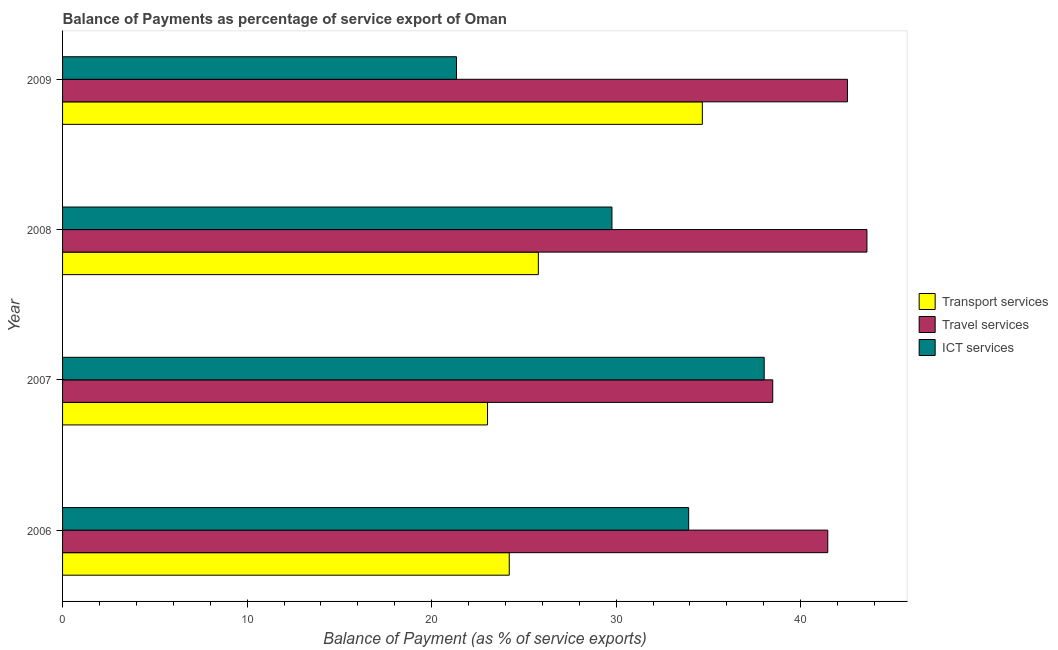How many different coloured bars are there?
Your answer should be compact. 3. How many groups of bars are there?
Make the answer very short. 4. How many bars are there on the 1st tick from the top?
Offer a terse response. 3. What is the balance of payment of ict services in 2008?
Provide a short and direct response. 29.77. Across all years, what is the maximum balance of payment of travel services?
Provide a short and direct response. 43.59. Across all years, what is the minimum balance of payment of ict services?
Keep it short and to the point. 21.35. What is the total balance of payment of ict services in the graph?
Your answer should be compact. 123.07. What is the difference between the balance of payment of ict services in 2006 and that in 2008?
Keep it short and to the point. 4.16. What is the difference between the balance of payment of ict services in 2006 and the balance of payment of travel services in 2008?
Provide a short and direct response. -9.66. What is the average balance of payment of transport services per year?
Provide a succinct answer. 26.92. In the year 2008, what is the difference between the balance of payment of travel services and balance of payment of ict services?
Offer a terse response. 13.82. What is the ratio of the balance of payment of travel services in 2006 to that in 2007?
Your answer should be very brief. 1.08. Is the balance of payment of ict services in 2006 less than that in 2009?
Offer a very short reply. No. Is the difference between the balance of payment of transport services in 2007 and 2009 greater than the difference between the balance of payment of travel services in 2007 and 2009?
Offer a terse response. No. What is the difference between the highest and the second highest balance of payment of travel services?
Your answer should be compact. 1.05. What is the difference between the highest and the lowest balance of payment of transport services?
Make the answer very short. 11.64. What does the 2nd bar from the top in 2006 represents?
Give a very brief answer. Travel services. What does the 2nd bar from the bottom in 2007 represents?
Your response must be concise. Travel services. Are all the bars in the graph horizontal?
Make the answer very short. Yes. Are the values on the major ticks of X-axis written in scientific E-notation?
Your answer should be compact. No. Does the graph contain grids?
Offer a very short reply. No. What is the title of the graph?
Offer a terse response. Balance of Payments as percentage of service export of Oman. Does "Nuclear sources" appear as one of the legend labels in the graph?
Make the answer very short. No. What is the label or title of the X-axis?
Give a very brief answer. Balance of Payment (as % of service exports). What is the Balance of Payment (as % of service exports) of Transport services in 2006?
Give a very brief answer. 24.21. What is the Balance of Payment (as % of service exports) of Travel services in 2006?
Your answer should be very brief. 41.47. What is the Balance of Payment (as % of service exports) in ICT services in 2006?
Your response must be concise. 33.93. What is the Balance of Payment (as % of service exports) of Transport services in 2007?
Provide a succinct answer. 23.03. What is the Balance of Payment (as % of service exports) in Travel services in 2007?
Give a very brief answer. 38.49. What is the Balance of Payment (as % of service exports) in ICT services in 2007?
Keep it short and to the point. 38.02. What is the Balance of Payment (as % of service exports) of Transport services in 2008?
Make the answer very short. 25.78. What is the Balance of Payment (as % of service exports) of Travel services in 2008?
Keep it short and to the point. 43.59. What is the Balance of Payment (as % of service exports) of ICT services in 2008?
Provide a short and direct response. 29.77. What is the Balance of Payment (as % of service exports) in Transport services in 2009?
Offer a very short reply. 34.67. What is the Balance of Payment (as % of service exports) in Travel services in 2009?
Your response must be concise. 42.54. What is the Balance of Payment (as % of service exports) in ICT services in 2009?
Your answer should be very brief. 21.35. Across all years, what is the maximum Balance of Payment (as % of service exports) in Transport services?
Make the answer very short. 34.67. Across all years, what is the maximum Balance of Payment (as % of service exports) in Travel services?
Offer a very short reply. 43.59. Across all years, what is the maximum Balance of Payment (as % of service exports) in ICT services?
Your answer should be compact. 38.02. Across all years, what is the minimum Balance of Payment (as % of service exports) of Transport services?
Offer a terse response. 23.03. Across all years, what is the minimum Balance of Payment (as % of service exports) in Travel services?
Provide a short and direct response. 38.49. Across all years, what is the minimum Balance of Payment (as % of service exports) of ICT services?
Make the answer very short. 21.35. What is the total Balance of Payment (as % of service exports) of Transport services in the graph?
Offer a terse response. 107.69. What is the total Balance of Payment (as % of service exports) of Travel services in the graph?
Keep it short and to the point. 166.08. What is the total Balance of Payment (as % of service exports) of ICT services in the graph?
Make the answer very short. 123.07. What is the difference between the Balance of Payment (as % of service exports) in Transport services in 2006 and that in 2007?
Ensure brevity in your answer.  1.18. What is the difference between the Balance of Payment (as % of service exports) in Travel services in 2006 and that in 2007?
Offer a terse response. 2.98. What is the difference between the Balance of Payment (as % of service exports) of ICT services in 2006 and that in 2007?
Provide a succinct answer. -4.09. What is the difference between the Balance of Payment (as % of service exports) in Transport services in 2006 and that in 2008?
Keep it short and to the point. -1.58. What is the difference between the Balance of Payment (as % of service exports) in Travel services in 2006 and that in 2008?
Provide a succinct answer. -2.12. What is the difference between the Balance of Payment (as % of service exports) in ICT services in 2006 and that in 2008?
Ensure brevity in your answer.  4.16. What is the difference between the Balance of Payment (as % of service exports) of Transport services in 2006 and that in 2009?
Give a very brief answer. -10.46. What is the difference between the Balance of Payment (as % of service exports) in Travel services in 2006 and that in 2009?
Offer a very short reply. -1.07. What is the difference between the Balance of Payment (as % of service exports) of ICT services in 2006 and that in 2009?
Offer a terse response. 12.58. What is the difference between the Balance of Payment (as % of service exports) in Transport services in 2007 and that in 2008?
Offer a terse response. -2.75. What is the difference between the Balance of Payment (as % of service exports) of Travel services in 2007 and that in 2008?
Make the answer very short. -5.1. What is the difference between the Balance of Payment (as % of service exports) of ICT services in 2007 and that in 2008?
Keep it short and to the point. 8.25. What is the difference between the Balance of Payment (as % of service exports) of Transport services in 2007 and that in 2009?
Provide a short and direct response. -11.64. What is the difference between the Balance of Payment (as % of service exports) of Travel services in 2007 and that in 2009?
Offer a terse response. -4.05. What is the difference between the Balance of Payment (as % of service exports) of ICT services in 2007 and that in 2009?
Ensure brevity in your answer.  16.67. What is the difference between the Balance of Payment (as % of service exports) in Transport services in 2008 and that in 2009?
Provide a succinct answer. -8.89. What is the difference between the Balance of Payment (as % of service exports) of Travel services in 2008 and that in 2009?
Offer a terse response. 1.05. What is the difference between the Balance of Payment (as % of service exports) of ICT services in 2008 and that in 2009?
Provide a short and direct response. 8.42. What is the difference between the Balance of Payment (as % of service exports) of Transport services in 2006 and the Balance of Payment (as % of service exports) of Travel services in 2007?
Your answer should be very brief. -14.28. What is the difference between the Balance of Payment (as % of service exports) of Transport services in 2006 and the Balance of Payment (as % of service exports) of ICT services in 2007?
Provide a short and direct response. -13.82. What is the difference between the Balance of Payment (as % of service exports) of Travel services in 2006 and the Balance of Payment (as % of service exports) of ICT services in 2007?
Offer a very short reply. 3.45. What is the difference between the Balance of Payment (as % of service exports) in Transport services in 2006 and the Balance of Payment (as % of service exports) in Travel services in 2008?
Provide a succinct answer. -19.38. What is the difference between the Balance of Payment (as % of service exports) in Transport services in 2006 and the Balance of Payment (as % of service exports) in ICT services in 2008?
Make the answer very short. -5.57. What is the difference between the Balance of Payment (as % of service exports) of Travel services in 2006 and the Balance of Payment (as % of service exports) of ICT services in 2008?
Offer a very short reply. 11.7. What is the difference between the Balance of Payment (as % of service exports) of Transport services in 2006 and the Balance of Payment (as % of service exports) of Travel services in 2009?
Your response must be concise. -18.33. What is the difference between the Balance of Payment (as % of service exports) of Transport services in 2006 and the Balance of Payment (as % of service exports) of ICT services in 2009?
Keep it short and to the point. 2.86. What is the difference between the Balance of Payment (as % of service exports) of Travel services in 2006 and the Balance of Payment (as % of service exports) of ICT services in 2009?
Ensure brevity in your answer.  20.12. What is the difference between the Balance of Payment (as % of service exports) in Transport services in 2007 and the Balance of Payment (as % of service exports) in Travel services in 2008?
Give a very brief answer. -20.56. What is the difference between the Balance of Payment (as % of service exports) in Transport services in 2007 and the Balance of Payment (as % of service exports) in ICT services in 2008?
Provide a succinct answer. -6.74. What is the difference between the Balance of Payment (as % of service exports) of Travel services in 2007 and the Balance of Payment (as % of service exports) of ICT services in 2008?
Provide a succinct answer. 8.71. What is the difference between the Balance of Payment (as % of service exports) of Transport services in 2007 and the Balance of Payment (as % of service exports) of Travel services in 2009?
Your answer should be compact. -19.51. What is the difference between the Balance of Payment (as % of service exports) of Transport services in 2007 and the Balance of Payment (as % of service exports) of ICT services in 2009?
Provide a succinct answer. 1.68. What is the difference between the Balance of Payment (as % of service exports) of Travel services in 2007 and the Balance of Payment (as % of service exports) of ICT services in 2009?
Your answer should be compact. 17.14. What is the difference between the Balance of Payment (as % of service exports) of Transport services in 2008 and the Balance of Payment (as % of service exports) of Travel services in 2009?
Provide a succinct answer. -16.75. What is the difference between the Balance of Payment (as % of service exports) of Transport services in 2008 and the Balance of Payment (as % of service exports) of ICT services in 2009?
Offer a very short reply. 4.44. What is the difference between the Balance of Payment (as % of service exports) of Travel services in 2008 and the Balance of Payment (as % of service exports) of ICT services in 2009?
Offer a terse response. 22.24. What is the average Balance of Payment (as % of service exports) in Transport services per year?
Give a very brief answer. 26.92. What is the average Balance of Payment (as % of service exports) in Travel services per year?
Offer a terse response. 41.52. What is the average Balance of Payment (as % of service exports) in ICT services per year?
Give a very brief answer. 30.77. In the year 2006, what is the difference between the Balance of Payment (as % of service exports) in Transport services and Balance of Payment (as % of service exports) in Travel services?
Provide a short and direct response. -17.26. In the year 2006, what is the difference between the Balance of Payment (as % of service exports) in Transport services and Balance of Payment (as % of service exports) in ICT services?
Provide a short and direct response. -9.72. In the year 2006, what is the difference between the Balance of Payment (as % of service exports) of Travel services and Balance of Payment (as % of service exports) of ICT services?
Your response must be concise. 7.54. In the year 2007, what is the difference between the Balance of Payment (as % of service exports) of Transport services and Balance of Payment (as % of service exports) of Travel services?
Your response must be concise. -15.46. In the year 2007, what is the difference between the Balance of Payment (as % of service exports) in Transport services and Balance of Payment (as % of service exports) in ICT services?
Provide a short and direct response. -14.99. In the year 2007, what is the difference between the Balance of Payment (as % of service exports) in Travel services and Balance of Payment (as % of service exports) in ICT services?
Make the answer very short. 0.46. In the year 2008, what is the difference between the Balance of Payment (as % of service exports) of Transport services and Balance of Payment (as % of service exports) of Travel services?
Provide a succinct answer. -17.81. In the year 2008, what is the difference between the Balance of Payment (as % of service exports) in Transport services and Balance of Payment (as % of service exports) in ICT services?
Your answer should be very brief. -3.99. In the year 2008, what is the difference between the Balance of Payment (as % of service exports) in Travel services and Balance of Payment (as % of service exports) in ICT services?
Provide a short and direct response. 13.82. In the year 2009, what is the difference between the Balance of Payment (as % of service exports) in Transport services and Balance of Payment (as % of service exports) in Travel services?
Your answer should be very brief. -7.87. In the year 2009, what is the difference between the Balance of Payment (as % of service exports) in Transport services and Balance of Payment (as % of service exports) in ICT services?
Your response must be concise. 13.32. In the year 2009, what is the difference between the Balance of Payment (as % of service exports) in Travel services and Balance of Payment (as % of service exports) in ICT services?
Your answer should be compact. 21.19. What is the ratio of the Balance of Payment (as % of service exports) of Transport services in 2006 to that in 2007?
Offer a terse response. 1.05. What is the ratio of the Balance of Payment (as % of service exports) in Travel services in 2006 to that in 2007?
Provide a short and direct response. 1.08. What is the ratio of the Balance of Payment (as % of service exports) of ICT services in 2006 to that in 2007?
Your answer should be compact. 0.89. What is the ratio of the Balance of Payment (as % of service exports) of Transport services in 2006 to that in 2008?
Provide a succinct answer. 0.94. What is the ratio of the Balance of Payment (as % of service exports) of Travel services in 2006 to that in 2008?
Your answer should be very brief. 0.95. What is the ratio of the Balance of Payment (as % of service exports) of ICT services in 2006 to that in 2008?
Your response must be concise. 1.14. What is the ratio of the Balance of Payment (as % of service exports) in Transport services in 2006 to that in 2009?
Make the answer very short. 0.7. What is the ratio of the Balance of Payment (as % of service exports) in Travel services in 2006 to that in 2009?
Keep it short and to the point. 0.97. What is the ratio of the Balance of Payment (as % of service exports) in ICT services in 2006 to that in 2009?
Keep it short and to the point. 1.59. What is the ratio of the Balance of Payment (as % of service exports) in Transport services in 2007 to that in 2008?
Your answer should be compact. 0.89. What is the ratio of the Balance of Payment (as % of service exports) in Travel services in 2007 to that in 2008?
Provide a succinct answer. 0.88. What is the ratio of the Balance of Payment (as % of service exports) in ICT services in 2007 to that in 2008?
Make the answer very short. 1.28. What is the ratio of the Balance of Payment (as % of service exports) in Transport services in 2007 to that in 2009?
Ensure brevity in your answer.  0.66. What is the ratio of the Balance of Payment (as % of service exports) of Travel services in 2007 to that in 2009?
Offer a very short reply. 0.9. What is the ratio of the Balance of Payment (as % of service exports) of ICT services in 2007 to that in 2009?
Your answer should be compact. 1.78. What is the ratio of the Balance of Payment (as % of service exports) in Transport services in 2008 to that in 2009?
Keep it short and to the point. 0.74. What is the ratio of the Balance of Payment (as % of service exports) in Travel services in 2008 to that in 2009?
Provide a short and direct response. 1.02. What is the ratio of the Balance of Payment (as % of service exports) in ICT services in 2008 to that in 2009?
Offer a terse response. 1.39. What is the difference between the highest and the second highest Balance of Payment (as % of service exports) of Transport services?
Provide a succinct answer. 8.89. What is the difference between the highest and the second highest Balance of Payment (as % of service exports) in Travel services?
Offer a terse response. 1.05. What is the difference between the highest and the second highest Balance of Payment (as % of service exports) in ICT services?
Provide a succinct answer. 4.09. What is the difference between the highest and the lowest Balance of Payment (as % of service exports) of Transport services?
Provide a short and direct response. 11.64. What is the difference between the highest and the lowest Balance of Payment (as % of service exports) in Travel services?
Offer a terse response. 5.1. What is the difference between the highest and the lowest Balance of Payment (as % of service exports) of ICT services?
Offer a very short reply. 16.67. 